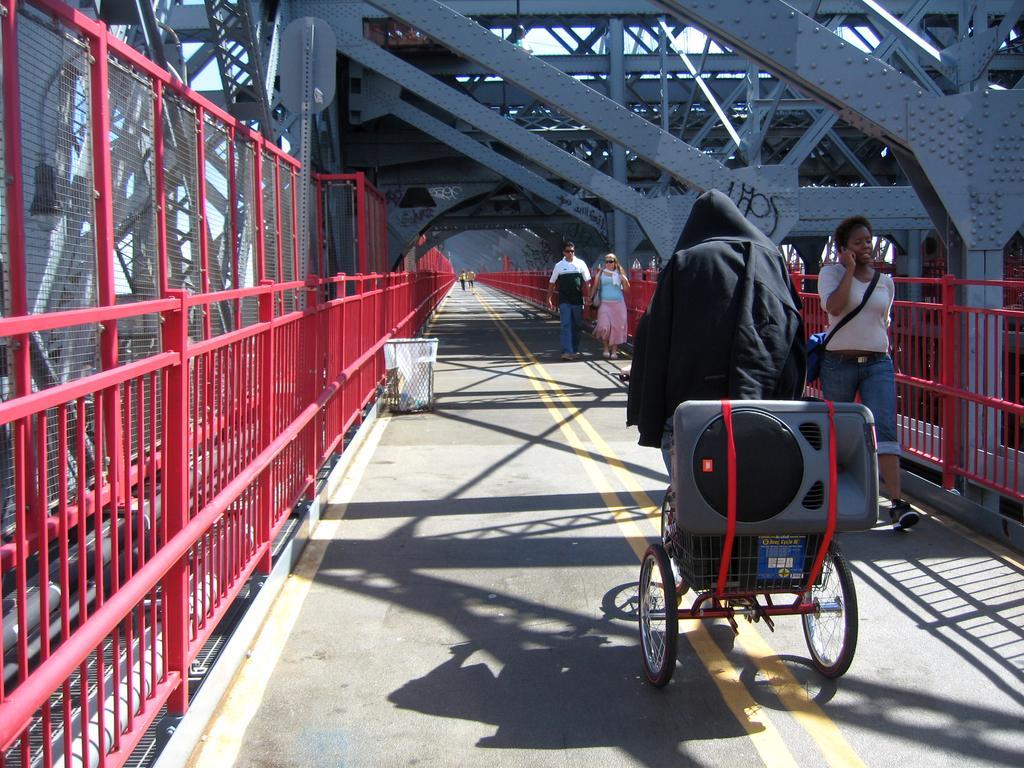Can you describe this image briefly? This is a bridge. Here I can see the road. On both sides of the road there is a red color railing. On the road, I can see few people are walking and a person is riding a bicycle. On the left side of this road there is a dustbin. 